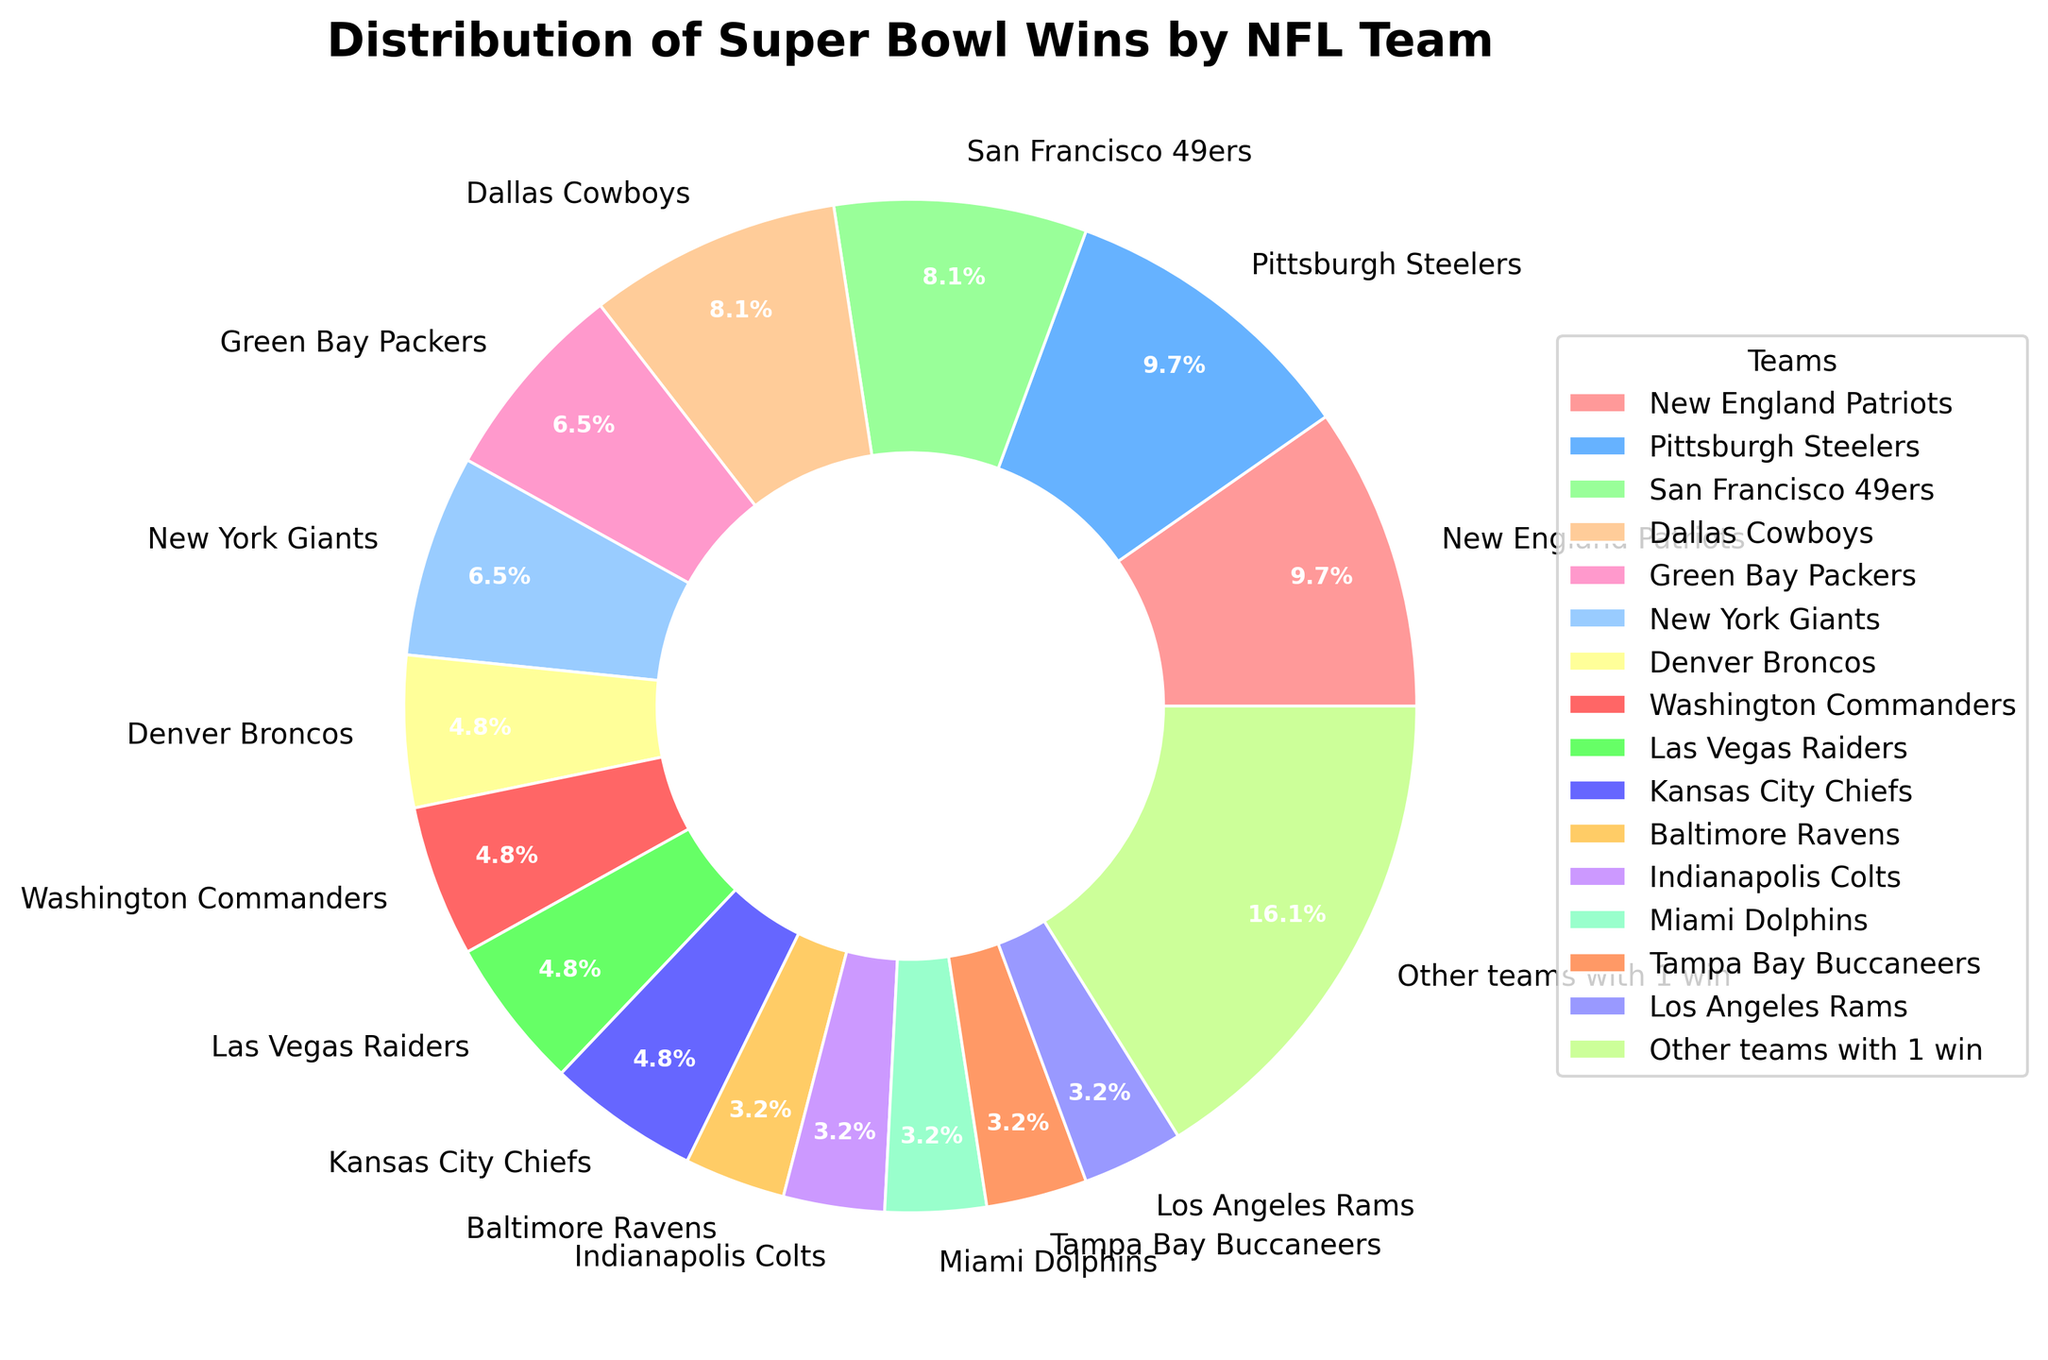Which team had the highest number of Super Bowl wins? By looking at the pie chart, the two largest sections are labeled "New England Patriots" and "Pittsburgh Steelers," both with 6 wins each. These two teams have the highest number of Super Bowl wins.
Answer: New England Patriots and Pittsburgh Steelers How many teams have won exactly 3 Super Bowls? By referring to the labels on the pie chart, the teams with exactly 3 Super Bowl wins are the Denver Broncos, Washington Commanders, Las Vegas Raiders, and Kansas City Chiefs. Counting these teams gives a total of four teams.
Answer: 4 What percentage of total Super Bowl wins is shared by the top four teams? From the pie chart, the top four teams (New England Patriots, Pittsburgh Steelers, San Francisco 49ers, and Dallas Cowboys) have won 6 + 6 + 5 + 5 = 22 Super Bowls. Dividing by the total number of wins and converting to percentage (22/61)*100 = 36.07%.
Answer: 36.07% Which sections of the pie chart are the same color? By visually inspecting the pie chart, different sections might have varying shades but are distinct in this specific pie chart to differentiate each team. No sections should be exactly the same color.
Answer: None How many more Super Bowls have the Green Bay Packers won compared to the Tampa Bay Buccaneers? The pie chart shows Green Bay Packers with 4 wins and Tampa Bay Buccaneers with 2 wins. Subtracting the Buccaneers' wins from the Packers' wins gives 4 - 2 = 2.
Answer: 2 Which two teams have an equal number of Super Bowl wins, and what is that number? The pie chart shows that both the New York Giants and Green Bay Packers each have 4 Super Bowl wins.
Answer: New York Giants and Green Bay Packers, 4 Among the teams with only 1 Super Bowl win, what percentage of the total Super Bowl wins do they represent? Referring to the "Other teams with 1 win" section, which has 10 wins. Dividing by the total number of wins and converting to percentage (10/61)*100 = 16.39%.
Answer: 16.39% Are there more teams with exactly 3 Super Bowl wins or teams with exactly 2 Super Bowl wins? According to the pie chart, there are 4 teams with exactly 3 wins (Denver Broncos, Washington Commanders, Las Vegas Raiders, Kansas City Chiefs) and 5 teams with exactly 2 wins (Baltimore Ravens, Indianapolis Colts, Miami Dolphins, Tampa Bay Buccaneers, Los Angeles Rams).
Answer: Teams with exactly 2 Super Bowl wins Which team with multiple Super Bowl wins has the least amount? The pie chart indicates that the teams with multiple wins but the least amount are the Baltimore Ravens, Indianapolis Colts, Miami Dolphins, Tampa Bay Buccaneers, and Los Angeles Rams, each with 2 wins.
Answer: Baltimore Ravens, Indianapolis Colts, Miami Dolphins, Tampa Bay Buccaneers, Los Angeles Rams 